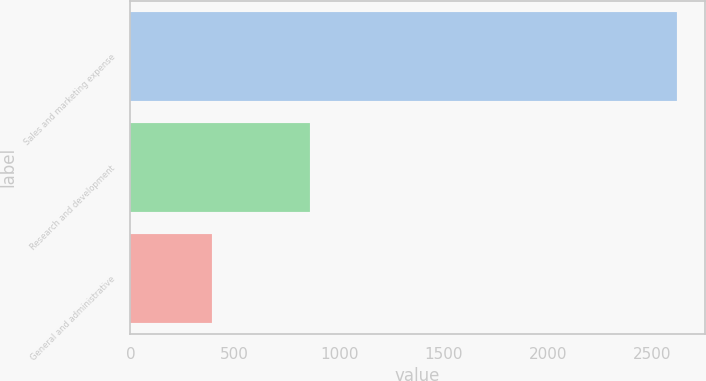<chart> <loc_0><loc_0><loc_500><loc_500><bar_chart><fcel>Sales and marketing expense<fcel>Research and development<fcel>General and administrative<nl><fcel>2622<fcel>862<fcel>390<nl></chart> 